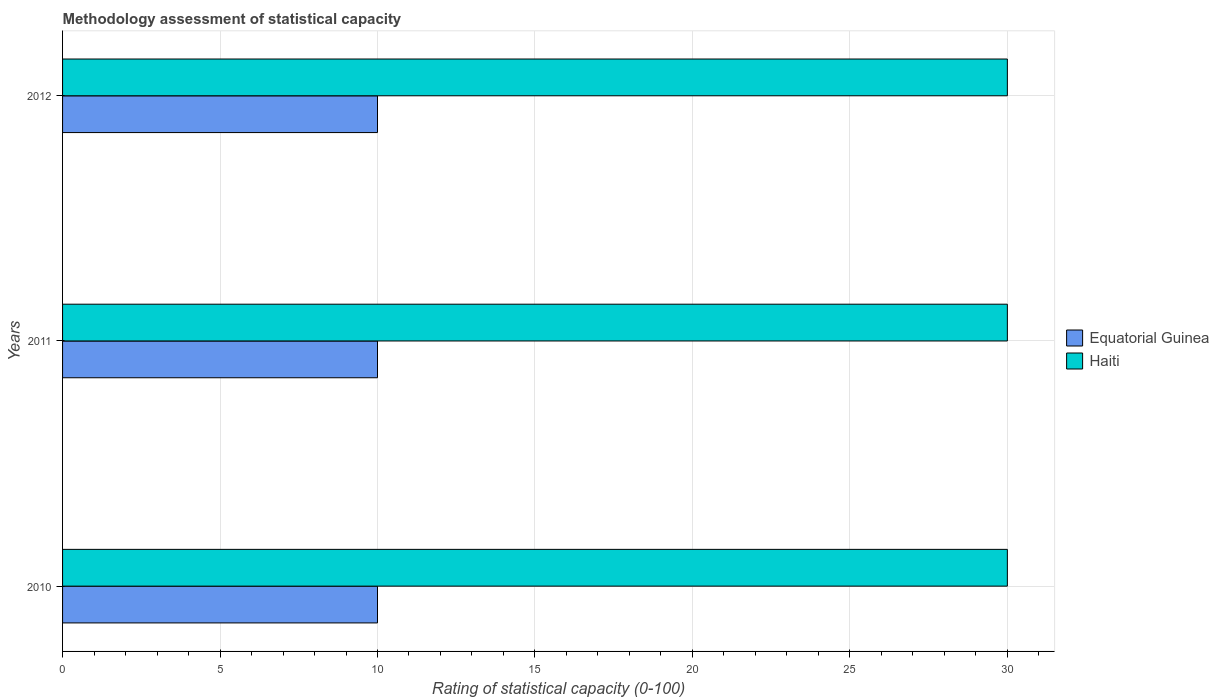How many groups of bars are there?
Keep it short and to the point. 3. Are the number of bars per tick equal to the number of legend labels?
Your response must be concise. Yes. Are the number of bars on each tick of the Y-axis equal?
Make the answer very short. Yes. How many bars are there on the 2nd tick from the top?
Provide a succinct answer. 2. How many bars are there on the 3rd tick from the bottom?
Ensure brevity in your answer.  2. What is the label of the 3rd group of bars from the top?
Make the answer very short. 2010. What is the rating of statistical capacity in Equatorial Guinea in 2012?
Keep it short and to the point. 10. Across all years, what is the maximum rating of statistical capacity in Equatorial Guinea?
Offer a terse response. 10. Across all years, what is the minimum rating of statistical capacity in Haiti?
Your answer should be compact. 30. In which year was the rating of statistical capacity in Haiti maximum?
Give a very brief answer. 2010. In which year was the rating of statistical capacity in Haiti minimum?
Your answer should be very brief. 2010. What is the total rating of statistical capacity in Haiti in the graph?
Give a very brief answer. 90. What is the difference between the rating of statistical capacity in Haiti in 2010 and that in 2012?
Your answer should be compact. 0. What is the difference between the rating of statistical capacity in Haiti in 2010 and the rating of statistical capacity in Equatorial Guinea in 2012?
Keep it short and to the point. 20. What is the average rating of statistical capacity in Haiti per year?
Provide a short and direct response. 30. What is the ratio of the rating of statistical capacity in Equatorial Guinea in 2010 to that in 2011?
Provide a succinct answer. 1. Is the difference between the rating of statistical capacity in Haiti in 2010 and 2012 greater than the difference between the rating of statistical capacity in Equatorial Guinea in 2010 and 2012?
Ensure brevity in your answer.  No. What is the difference between the highest and the second highest rating of statistical capacity in Haiti?
Provide a short and direct response. 0. In how many years, is the rating of statistical capacity in Haiti greater than the average rating of statistical capacity in Haiti taken over all years?
Provide a short and direct response. 0. Is the sum of the rating of statistical capacity in Haiti in 2010 and 2011 greater than the maximum rating of statistical capacity in Equatorial Guinea across all years?
Give a very brief answer. Yes. What does the 1st bar from the top in 2011 represents?
Give a very brief answer. Haiti. What does the 2nd bar from the bottom in 2012 represents?
Ensure brevity in your answer.  Haiti. Are all the bars in the graph horizontal?
Ensure brevity in your answer.  Yes. What is the difference between two consecutive major ticks on the X-axis?
Give a very brief answer. 5. Where does the legend appear in the graph?
Your response must be concise. Center right. What is the title of the graph?
Offer a terse response. Methodology assessment of statistical capacity. What is the label or title of the X-axis?
Provide a short and direct response. Rating of statistical capacity (0-100). What is the Rating of statistical capacity (0-100) of Haiti in 2010?
Offer a terse response. 30. What is the Rating of statistical capacity (0-100) in Equatorial Guinea in 2011?
Your response must be concise. 10. What is the Rating of statistical capacity (0-100) in Haiti in 2011?
Provide a succinct answer. 30. What is the Rating of statistical capacity (0-100) in Equatorial Guinea in 2012?
Offer a terse response. 10. What is the Rating of statistical capacity (0-100) of Haiti in 2012?
Provide a succinct answer. 30. What is the difference between the Rating of statistical capacity (0-100) of Equatorial Guinea in 2010 and that in 2012?
Your answer should be compact. 0. What is the difference between the Rating of statistical capacity (0-100) of Haiti in 2010 and that in 2012?
Your answer should be compact. 0. What is the difference between the Rating of statistical capacity (0-100) in Equatorial Guinea in 2010 and the Rating of statistical capacity (0-100) in Haiti in 2012?
Make the answer very short. -20. In the year 2010, what is the difference between the Rating of statistical capacity (0-100) in Equatorial Guinea and Rating of statistical capacity (0-100) in Haiti?
Offer a very short reply. -20. In the year 2011, what is the difference between the Rating of statistical capacity (0-100) of Equatorial Guinea and Rating of statistical capacity (0-100) of Haiti?
Make the answer very short. -20. In the year 2012, what is the difference between the Rating of statistical capacity (0-100) of Equatorial Guinea and Rating of statistical capacity (0-100) of Haiti?
Your response must be concise. -20. What is the ratio of the Rating of statistical capacity (0-100) in Equatorial Guinea in 2010 to that in 2011?
Your answer should be compact. 1. What is the ratio of the Rating of statistical capacity (0-100) of Haiti in 2010 to that in 2011?
Offer a very short reply. 1. What is the ratio of the Rating of statistical capacity (0-100) of Equatorial Guinea in 2010 to that in 2012?
Provide a succinct answer. 1. What is the ratio of the Rating of statistical capacity (0-100) in Haiti in 2011 to that in 2012?
Provide a short and direct response. 1. What is the difference between the highest and the lowest Rating of statistical capacity (0-100) of Haiti?
Your answer should be compact. 0. 